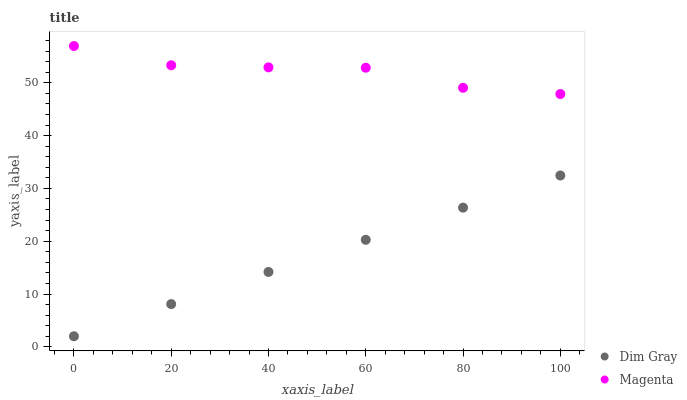Does Dim Gray have the minimum area under the curve?
Answer yes or no. Yes. Does Magenta have the maximum area under the curve?
Answer yes or no. Yes. Does Dim Gray have the maximum area under the curve?
Answer yes or no. No. Is Dim Gray the smoothest?
Answer yes or no. Yes. Is Magenta the roughest?
Answer yes or no. Yes. Is Dim Gray the roughest?
Answer yes or no. No. Does Dim Gray have the lowest value?
Answer yes or no. Yes. Does Magenta have the highest value?
Answer yes or no. Yes. Does Dim Gray have the highest value?
Answer yes or no. No. Is Dim Gray less than Magenta?
Answer yes or no. Yes. Is Magenta greater than Dim Gray?
Answer yes or no. Yes. Does Dim Gray intersect Magenta?
Answer yes or no. No. 